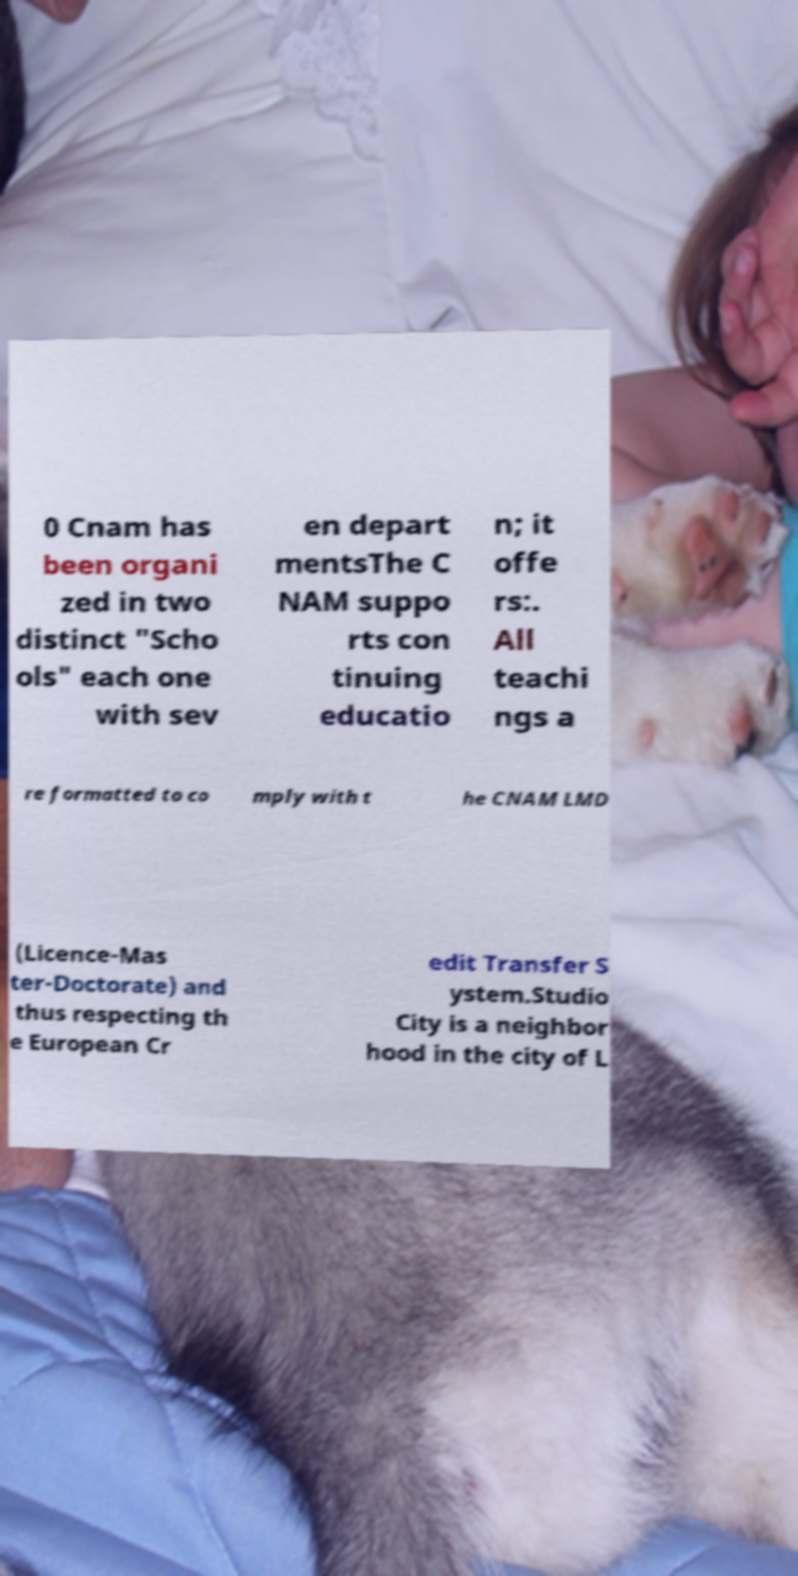Could you assist in decoding the text presented in this image and type it out clearly? 0 Cnam has been organi zed in two distinct "Scho ols" each one with sev en depart mentsThe C NAM suppo rts con tinuing educatio n; it offe rs:. All teachi ngs a re formatted to co mply with t he CNAM LMD (Licence-Mas ter-Doctorate) and thus respecting th e European Cr edit Transfer S ystem.Studio City is a neighbor hood in the city of L 